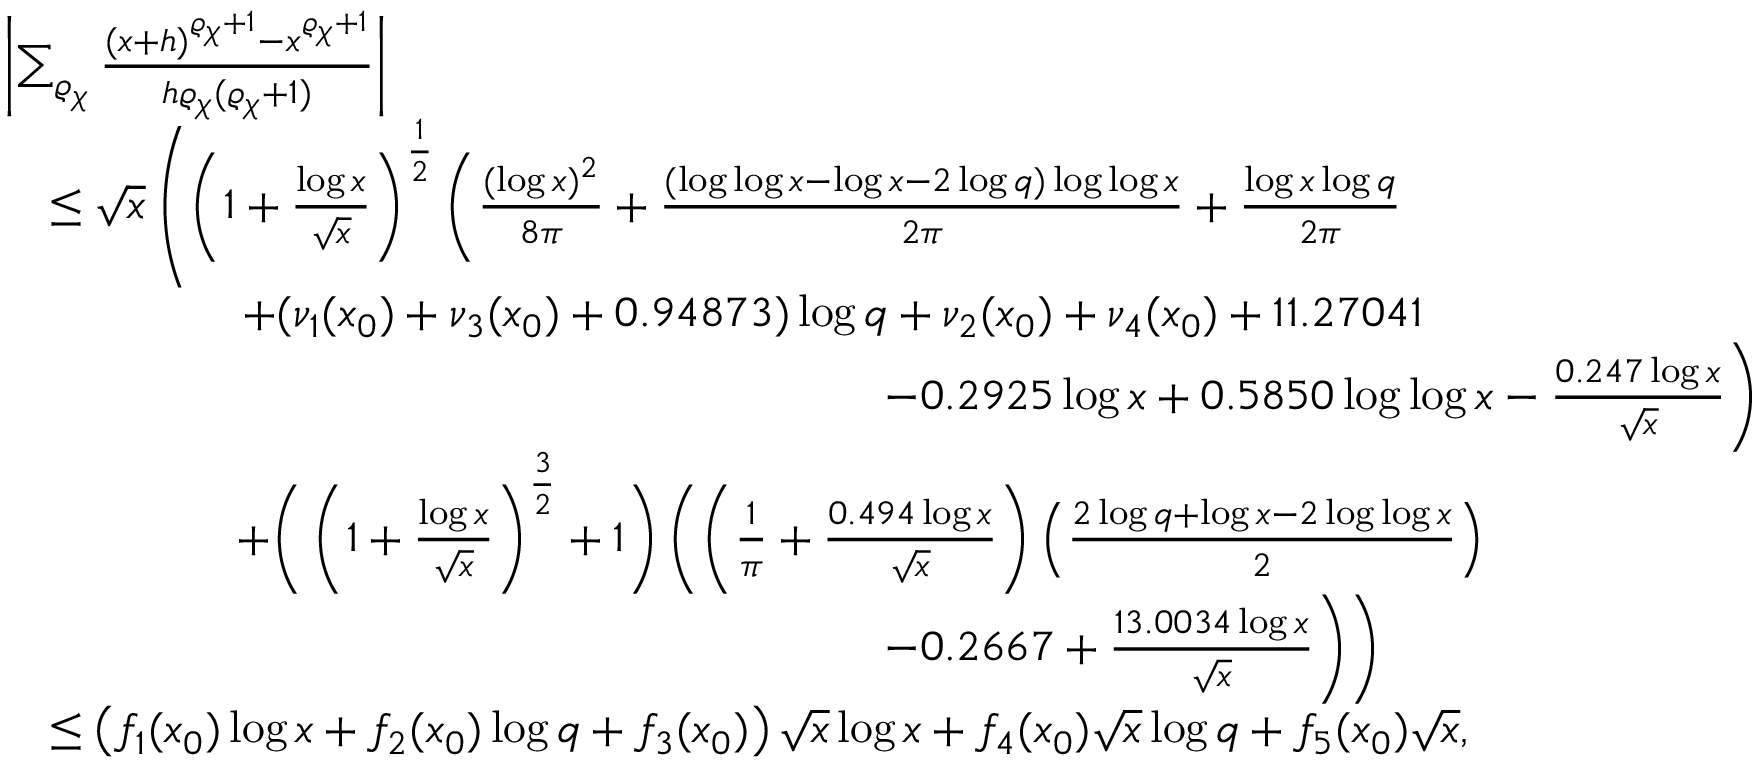<formula> <loc_0><loc_0><loc_500><loc_500>\begin{array} { r l } & { \left | \sum _ { \varrho _ { \chi } } \frac { ( x + h ) ^ { \varrho _ { \chi } + 1 } - x ^ { \varrho _ { \chi } + 1 } } { h \varrho _ { \chi } ( \varrho _ { \chi } + 1 ) } \right | } \\ & { \quad \leq \sqrt { x } \left ( \left ( 1 + \frac { \log { x } } { \sqrt { x } } \right ) ^ { \frac { 1 } { 2 } } \left ( \frac { ( \log { x } ) ^ { 2 } } { 8 \pi } + \frac { ( \log \log { x } - \log { x } - 2 \log { q } ) \log \log { x } } { 2 \pi } + \frac { \log { x } \log { q } } { 2 \pi } } \\ & { \quad + ( \nu _ { 1 } ( x _ { 0 } ) + \nu _ { 3 } ( x _ { 0 } ) + 0 . 9 4 8 7 3 ) \log { q } + \nu _ { 2 } ( x _ { 0 } ) + \nu _ { 4 } ( x _ { 0 } ) + 1 1 . 2 7 0 4 1 } \\ & { \quad - 0 . 2 9 2 5 \log { x } + 0 . 5 8 5 0 \log \log { x } - \frac { 0 . 2 4 7 \log { x } } { \sqrt { x } } \right ) } \\ & { \quad + \left ( \left ( 1 + \frac { \log { x } } { \sqrt { x } } \right ) ^ { \frac { 3 } { 2 } } + 1 \right ) \left ( \left ( \frac { 1 } { \pi } + \frac { 0 . 4 9 4 \log { x } } { \sqrt { x } } \right ) \left ( \frac { 2 \log { q } + \log { x } - 2 \log \log { x } } { 2 } \right ) } \\ & { \quad - 0 . 2 6 6 7 + \frac { 1 3 . 0 0 3 4 \log { x } } { \sqrt { x } } \right ) \right ) } \\ & { \quad \leq \left ( f _ { 1 } ( x _ { 0 } ) \log { x } + f _ { 2 } ( x _ { 0 } ) \log { q } + f _ { 3 } ( x _ { 0 } ) \right ) \sqrt { x } \log { x } + f _ { 4 } ( x _ { 0 } ) \sqrt { x } \log { q } + f _ { 5 } ( x _ { 0 } ) \sqrt { x } , } \end{array}</formula> 